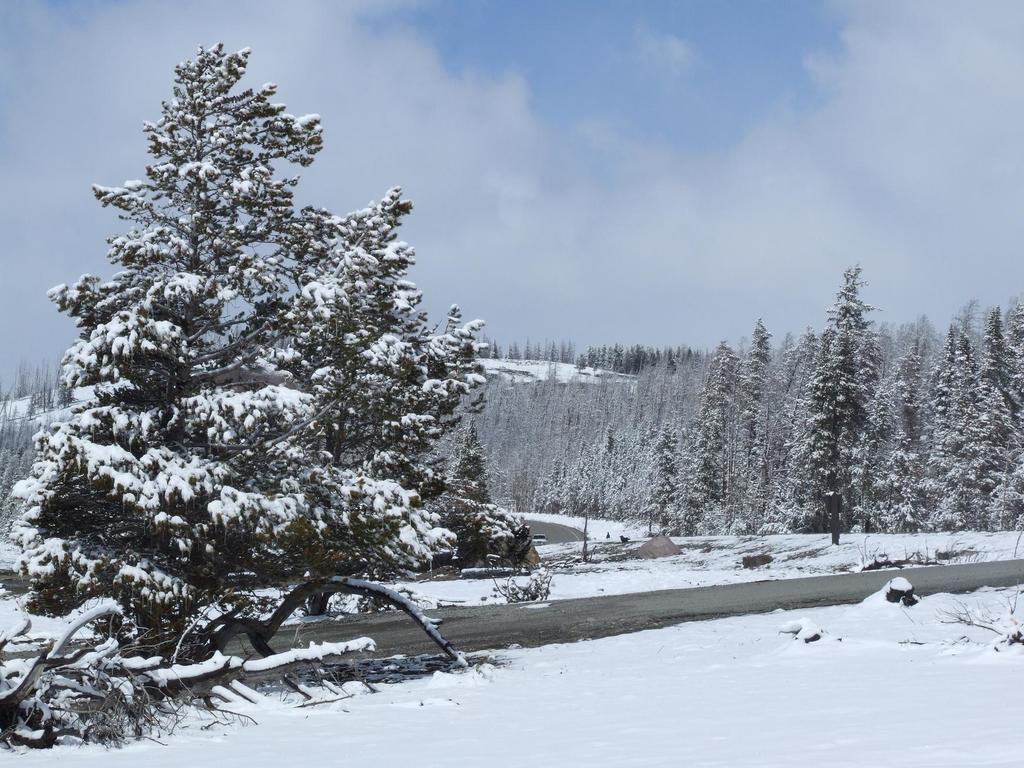Could you give a brief overview of what you see in this image? In this picture we can see snow at the bottom, in the background there are some trees, we can see the sky and clouds at the top of the picture. 